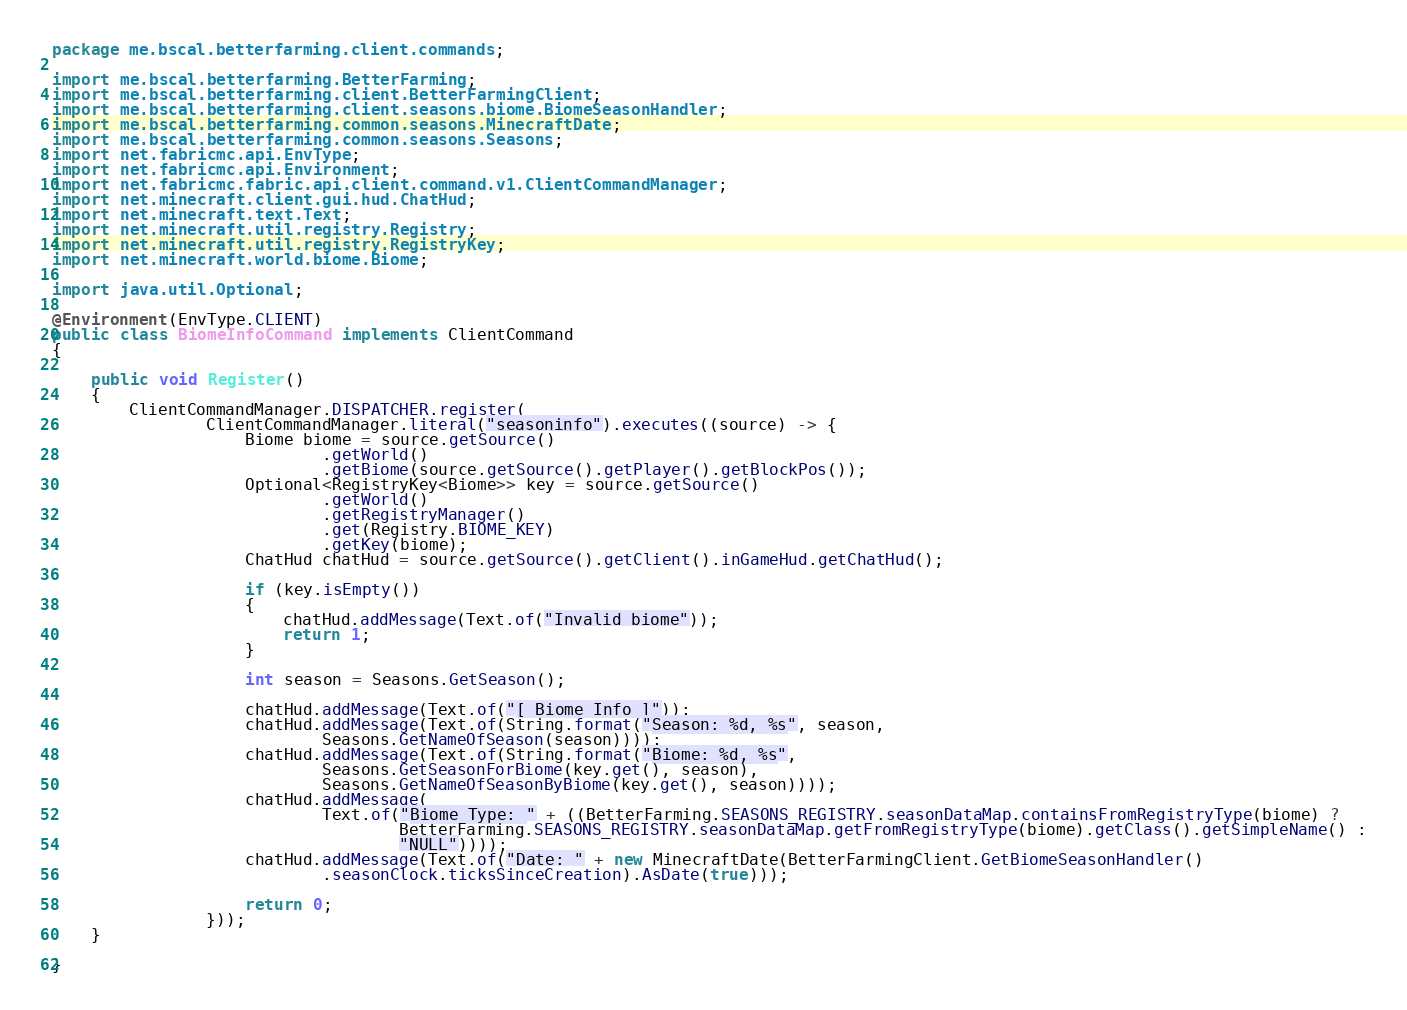<code> <loc_0><loc_0><loc_500><loc_500><_Java_>package me.bscal.betterfarming.client.commands;

import me.bscal.betterfarming.BetterFarming;
import me.bscal.betterfarming.client.BetterFarmingClient;
import me.bscal.betterfarming.client.seasons.biome.BiomeSeasonHandler;
import me.bscal.betterfarming.common.seasons.MinecraftDate;
import me.bscal.betterfarming.common.seasons.Seasons;
import net.fabricmc.api.EnvType;
import net.fabricmc.api.Environment;
import net.fabricmc.fabric.api.client.command.v1.ClientCommandManager;
import net.minecraft.client.gui.hud.ChatHud;
import net.minecraft.text.Text;
import net.minecraft.util.registry.Registry;
import net.minecraft.util.registry.RegistryKey;
import net.minecraft.world.biome.Biome;

import java.util.Optional;

@Environment(EnvType.CLIENT)
public class BiomeInfoCommand implements ClientCommand
{

	public void Register()
	{
		ClientCommandManager.DISPATCHER.register(
				ClientCommandManager.literal("seasoninfo").executes((source) -> {
					Biome biome = source.getSource()
							.getWorld()
							.getBiome(source.getSource().getPlayer().getBlockPos());
					Optional<RegistryKey<Biome>> key = source.getSource()
							.getWorld()
							.getRegistryManager()
							.get(Registry.BIOME_KEY)
							.getKey(biome);
					ChatHud chatHud = source.getSource().getClient().inGameHud.getChatHud();

					if (key.isEmpty())
					{
						chatHud.addMessage(Text.of("Invalid biome"));
						return 1;
					}

					int season = Seasons.GetSeason();

					chatHud.addMessage(Text.of("[ Biome Info ]"));
					chatHud.addMessage(Text.of(String.format("Season: %d, %s", season,
							Seasons.GetNameOfSeason(season))));
					chatHud.addMessage(Text.of(String.format("Biome: %d, %s",
							Seasons.GetSeasonForBiome(key.get(), season),
							Seasons.GetNameOfSeasonByBiome(key.get(), season))));
					chatHud.addMessage(
							Text.of("Biome Type: " + ((BetterFarming.SEASONS_REGISTRY.seasonDataMap.containsFromRegistryType(biome) ?
									BetterFarming.SEASONS_REGISTRY.seasonDataMap.getFromRegistryType(biome).getClass().getSimpleName() :
									"NULL"))));
					chatHud.addMessage(Text.of("Date: " + new MinecraftDate(BetterFarmingClient.GetBiomeSeasonHandler()
							.seasonClock.ticksSinceCreation).AsDate(true)));

					return 0;
				}));
	}

}
</code> 